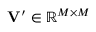Convert formula to latex. <formula><loc_0><loc_0><loc_500><loc_500>V ^ { \prime } \in \mathbb { R } ^ { M \times M }</formula> 